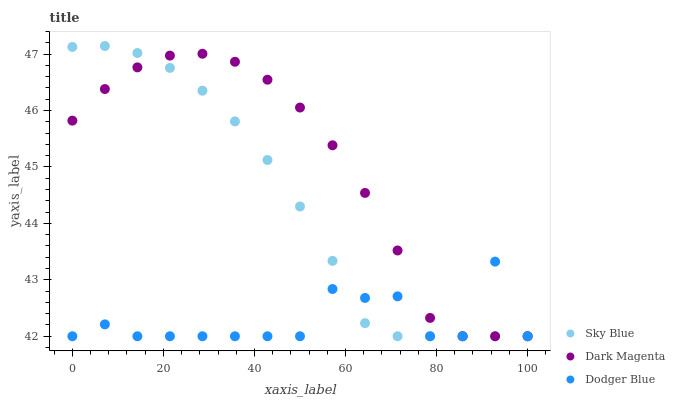Does Dodger Blue have the minimum area under the curve?
Answer yes or no. Yes. Does Dark Magenta have the maximum area under the curve?
Answer yes or no. Yes. Does Dark Magenta have the minimum area under the curve?
Answer yes or no. No. Does Dodger Blue have the maximum area under the curve?
Answer yes or no. No. Is Sky Blue the smoothest?
Answer yes or no. Yes. Is Dodger Blue the roughest?
Answer yes or no. Yes. Is Dark Magenta the smoothest?
Answer yes or no. No. Is Dark Magenta the roughest?
Answer yes or no. No. Does Sky Blue have the lowest value?
Answer yes or no. Yes. Does Sky Blue have the highest value?
Answer yes or no. Yes. Does Dark Magenta have the highest value?
Answer yes or no. No. Does Sky Blue intersect Dark Magenta?
Answer yes or no. Yes. Is Sky Blue less than Dark Magenta?
Answer yes or no. No. Is Sky Blue greater than Dark Magenta?
Answer yes or no. No. 